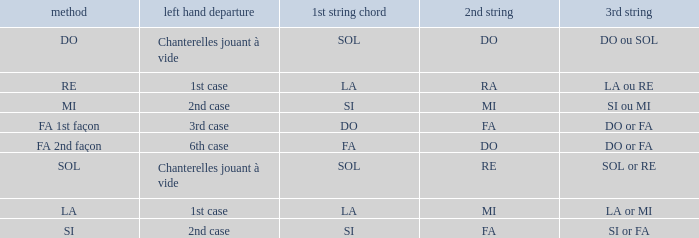For a 1st string of si Accord du and a 2nd string of mi what is the 3rd string? SI ou MI. 